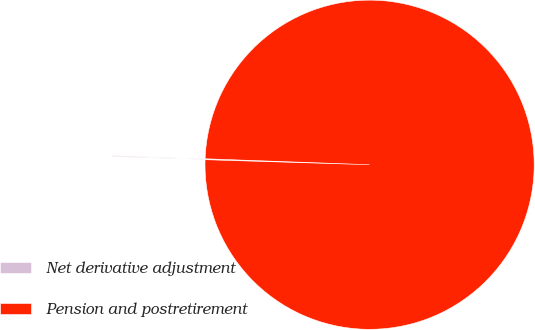Convert chart to OTSL. <chart><loc_0><loc_0><loc_500><loc_500><pie_chart><fcel>Net derivative adjustment<fcel>Pension and postretirement<nl><fcel>0.09%<fcel>99.91%<nl></chart> 